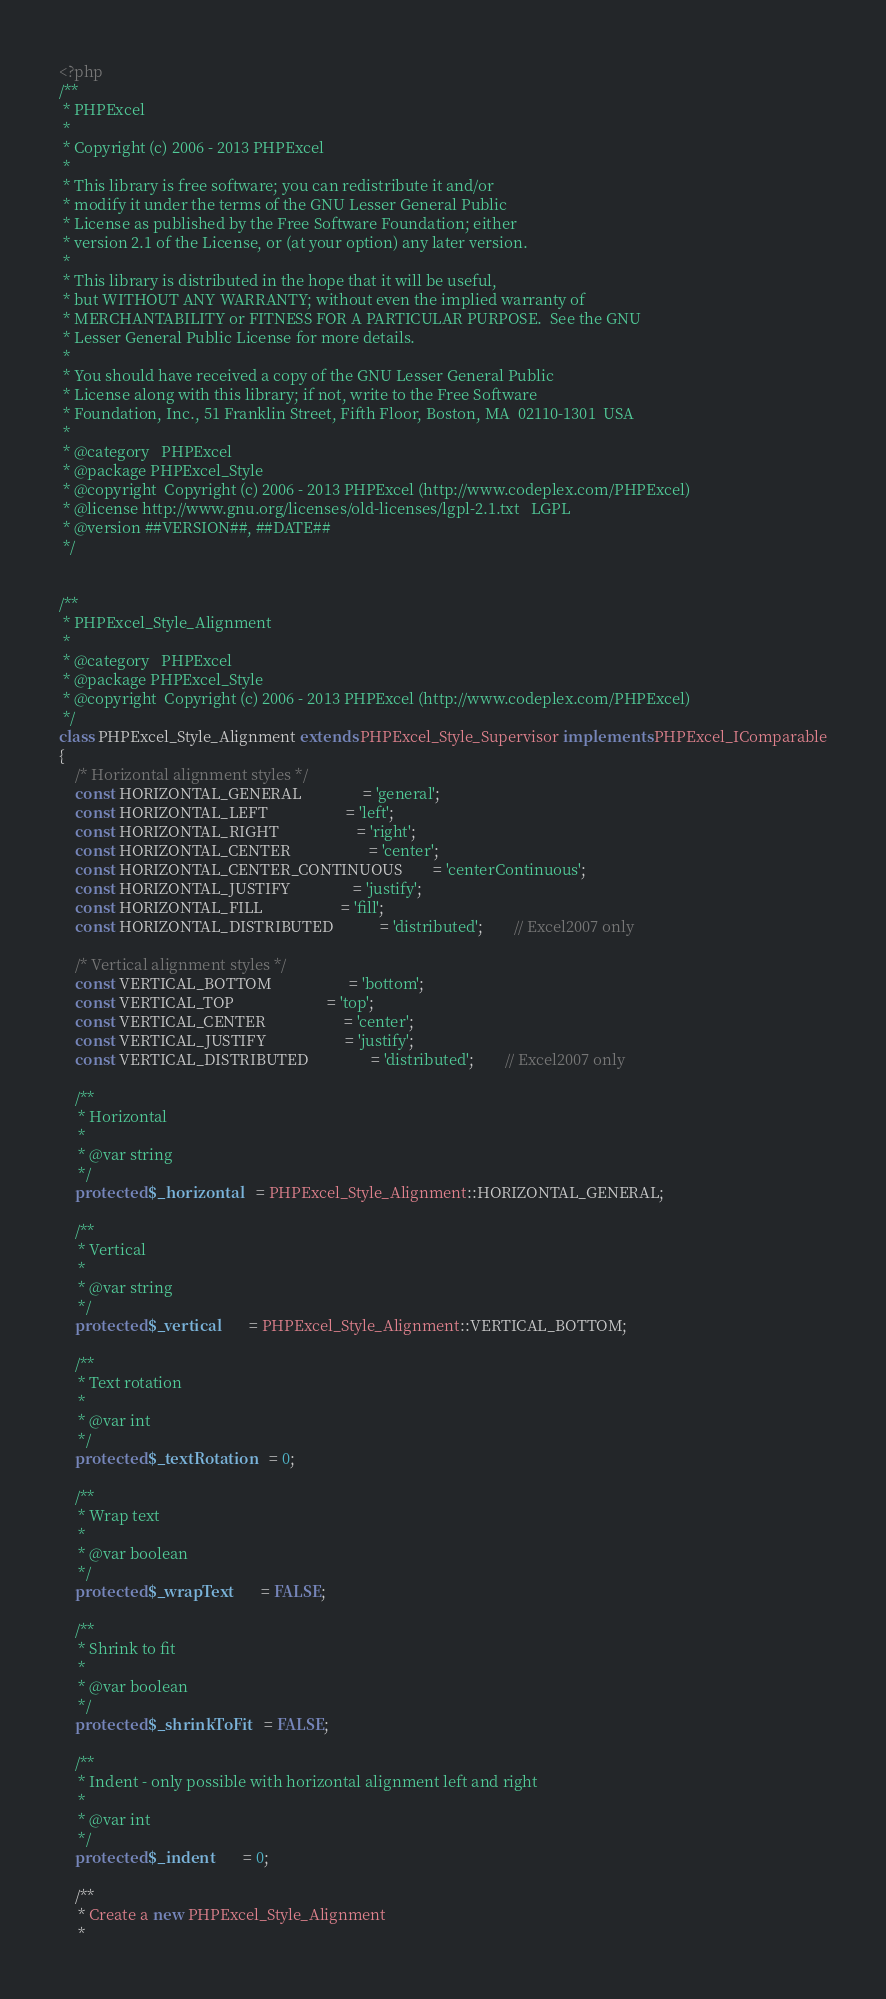Convert code to text. <code><loc_0><loc_0><loc_500><loc_500><_PHP_><?php
/**
 * PHPExcel
 *
 * Copyright (c) 2006 - 2013 PHPExcel
 *
 * This library is free software; you can redistribute it and/or
 * modify it under the terms of the GNU Lesser General Public
 * License as published by the Free Software Foundation; either
 * version 2.1 of the License, or (at your option) any later version.
 *
 * This library is distributed in the hope that it will be useful,
 * but WITHOUT ANY WARRANTY; without even the implied warranty of
 * MERCHANTABILITY or FITNESS FOR A PARTICULAR PURPOSE.  See the GNU
 * Lesser General Public License for more details.
 *
 * You should have received a copy of the GNU Lesser General Public
 * License along with this library; if not, write to the Free Software
 * Foundation, Inc., 51 Franklin Street, Fifth Floor, Boston, MA  02110-1301  USA
 *
 * @category   PHPExcel
 * @package	PHPExcel_Style
 * @copyright  Copyright (c) 2006 - 2013 PHPExcel (http://www.codeplex.com/PHPExcel)
 * @license	http://www.gnu.org/licenses/old-licenses/lgpl-2.1.txt	LGPL
 * @version	##VERSION##, ##DATE##
 */


/**
 * PHPExcel_Style_Alignment
 *
 * @category   PHPExcel
 * @package	PHPExcel_Style
 * @copyright  Copyright (c) 2006 - 2013 PHPExcel (http://www.codeplex.com/PHPExcel)
 */
class PHPExcel_Style_Alignment extends PHPExcel_Style_Supervisor implements PHPExcel_IComparable
{
	/* Horizontal alignment styles */
	const HORIZONTAL_GENERAL				= 'general';
	const HORIZONTAL_LEFT					= 'left';
	const HORIZONTAL_RIGHT					= 'right';
	const HORIZONTAL_CENTER					= 'center';
	const HORIZONTAL_CENTER_CONTINUOUS		= 'centerContinuous';
	const HORIZONTAL_JUSTIFY				= 'justify';
	const HORIZONTAL_FILL				    = 'fill';
	const HORIZONTAL_DISTRIBUTED		    = 'distributed';        // Excel2007 only

	/* Vertical alignment styles */
	const VERTICAL_BOTTOM					= 'bottom';
	const VERTICAL_TOP						= 'top';
	const VERTICAL_CENTER					= 'center';
	const VERTICAL_JUSTIFY					= 'justify';
	const VERTICAL_DISTRIBUTED		        = 'distributed';        // Excel2007 only

	/**
	 * Horizontal
	 *
	 * @var string
	 */
	protected $_horizontal	= PHPExcel_Style_Alignment::HORIZONTAL_GENERAL;

	/**
	 * Vertical
	 *
	 * @var string
	 */
	protected $_vertical		= PHPExcel_Style_Alignment::VERTICAL_BOTTOM;

	/**
	 * Text rotation
	 *
	 * @var int
	 */
	protected $_textRotation	= 0;

	/**
	 * Wrap text
	 *
	 * @var boolean
	 */
	protected $_wrapText		= FALSE;

	/**
	 * Shrink to fit
	 *
	 * @var boolean
	 */
	protected $_shrinkToFit	= FALSE;

	/**
	 * Indent - only possible with horizontal alignment left and right
	 *
	 * @var int
	 */
	protected $_indent		= 0;

	/**
	 * Create a new PHPExcel_Style_Alignment
	 *</code> 